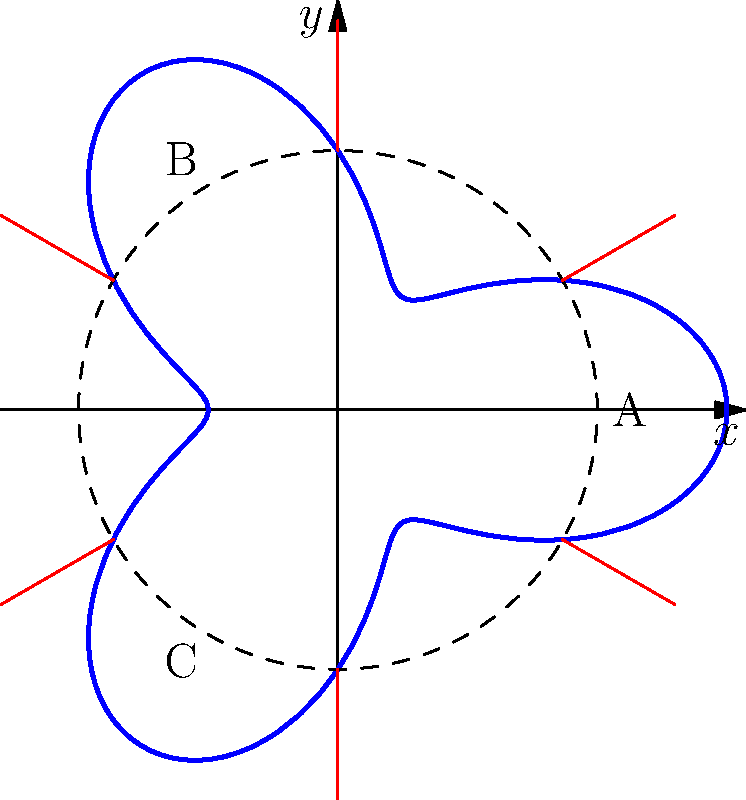As a contract attorney specializing in military aid and defense contracts, you are tasked with optimizing the distribution of defense resources across a circular region. The region's boundary is defined by the polar equation $r = 2 + \cos(3\theta)$, where $r$ is measured in hundreds of kilometers. Three key strategic points A, B, and C are located at $(2,0)$, $(-1,\sqrt{3})$, and $(-1,-\sqrt{3})$ respectively. What is the total area (in square hundreds of kilometers) that needs to be covered by the defense system to ensure protection of the entire region? To solve this problem, we need to follow these steps:

1) The area of a region in polar coordinates is given by the formula:

   $$A = \frac{1}{2} \int_{0}^{2\pi} r^2(\theta) d\theta$$

2) In our case, $r(\theta) = 2 + \cos(3\theta)$. We need to square this:

   $$r^2(\theta) = (2 + \cos(3\theta))^2 = 4 + 4\cos(3\theta) + \cos^2(3\theta)$$

3) Now, we can integrate this from 0 to $2\pi$:

   $$A = \frac{1}{2} \int_{0}^{2\pi} (4 + 4\cos(3\theta) + \cos^2(3\theta)) d\theta$$

4) Let's break this into parts:
   
   - $\int_{0}^{2\pi} 4 d\theta = 8\pi$
   - $\int_{0}^{2\pi} 4\cos(3\theta) d\theta = 0$ (because it's a full period of a cosine function)
   - $\int_{0}^{2\pi} \cos^2(3\theta) d\theta = \pi$ (this is a standard result)

5) Adding these up:

   $$A = \frac{1}{2} (8\pi + 0 + \pi) = \frac{9\pi}{2}$$

6) Therefore, the total area is $\frac{9\pi}{2}$ square hundreds of kilometers.
Answer: $\frac{9\pi}{2}$ square hundreds of kilometers 